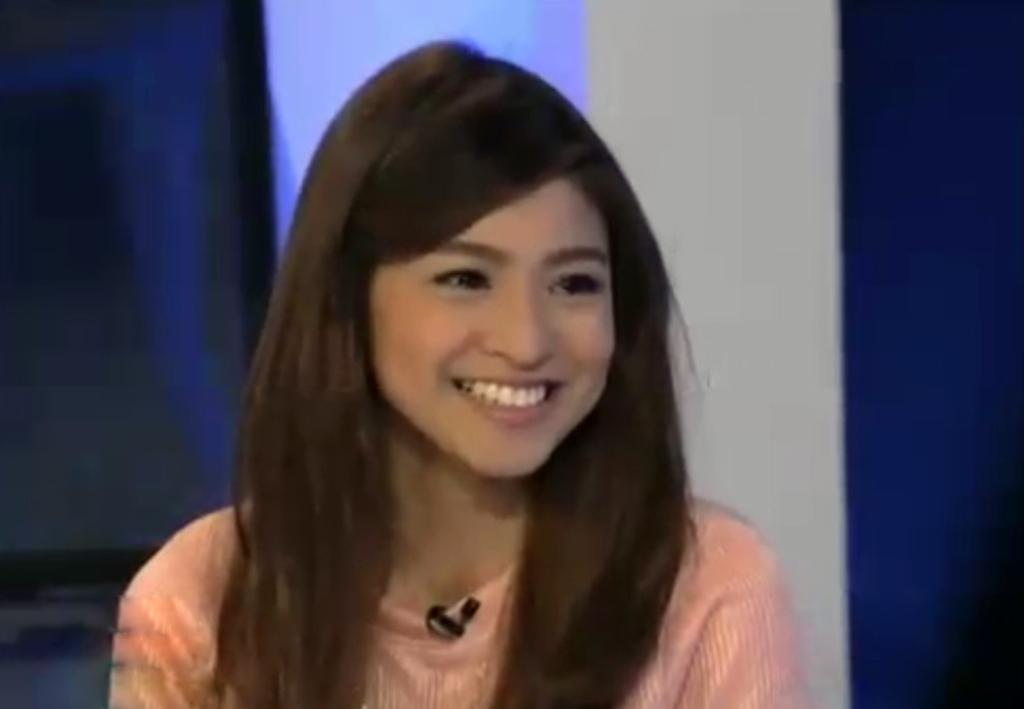In one or two sentences, can you explain what this image depicts? In this image I can see a woman and I can see she is wearing cream colour dress. I can also see smile on her face and here I can see a mic. 